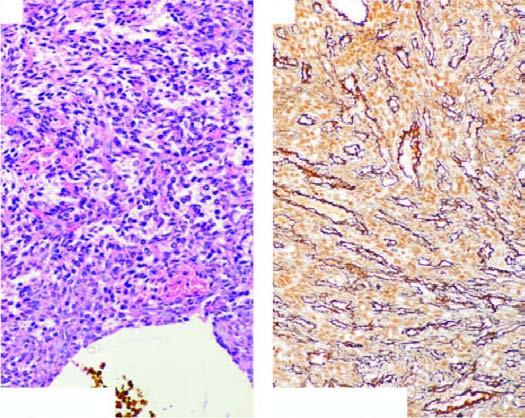what do these tumour cells have?
Answer the question using a single word or phrase. Bland nuclei and few mitoses 